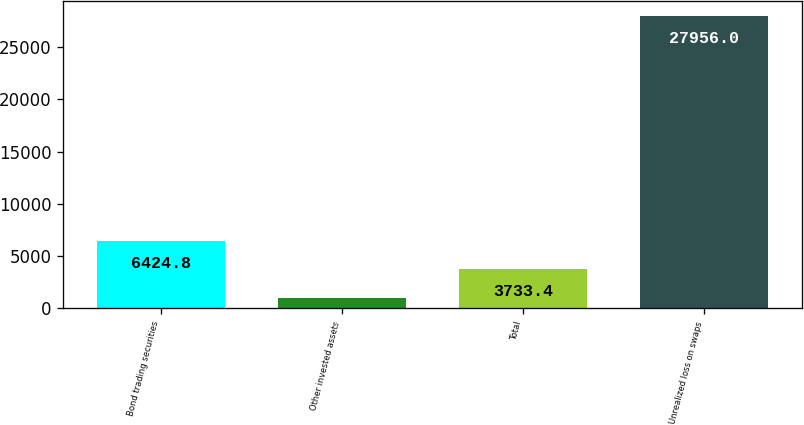Convert chart to OTSL. <chart><loc_0><loc_0><loc_500><loc_500><bar_chart><fcel>Bond trading securities<fcel>Other invested assets<fcel>Total<fcel>Unrealized loss on swaps<nl><fcel>6424.8<fcel>1042<fcel>3733.4<fcel>27956<nl></chart> 